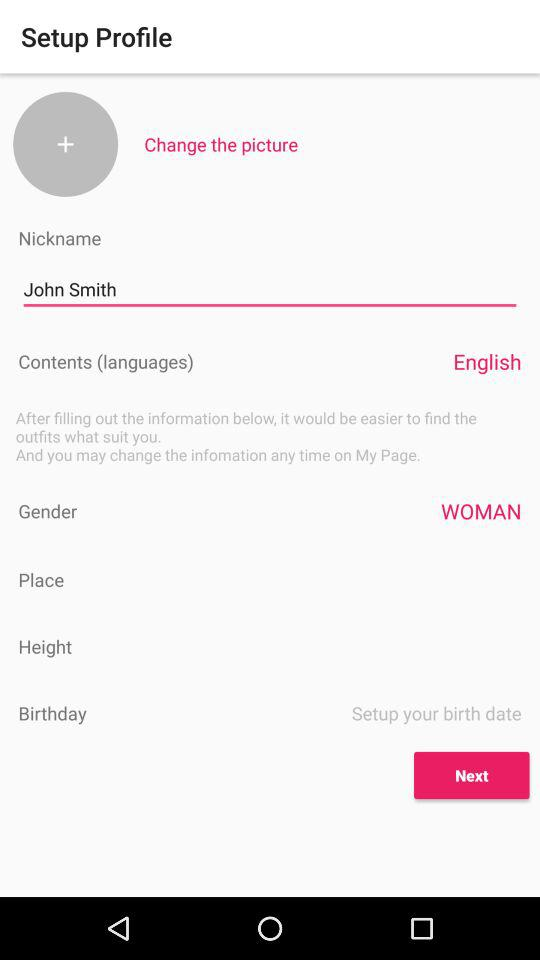What is the name of the user? The name of the user is John Smith. 